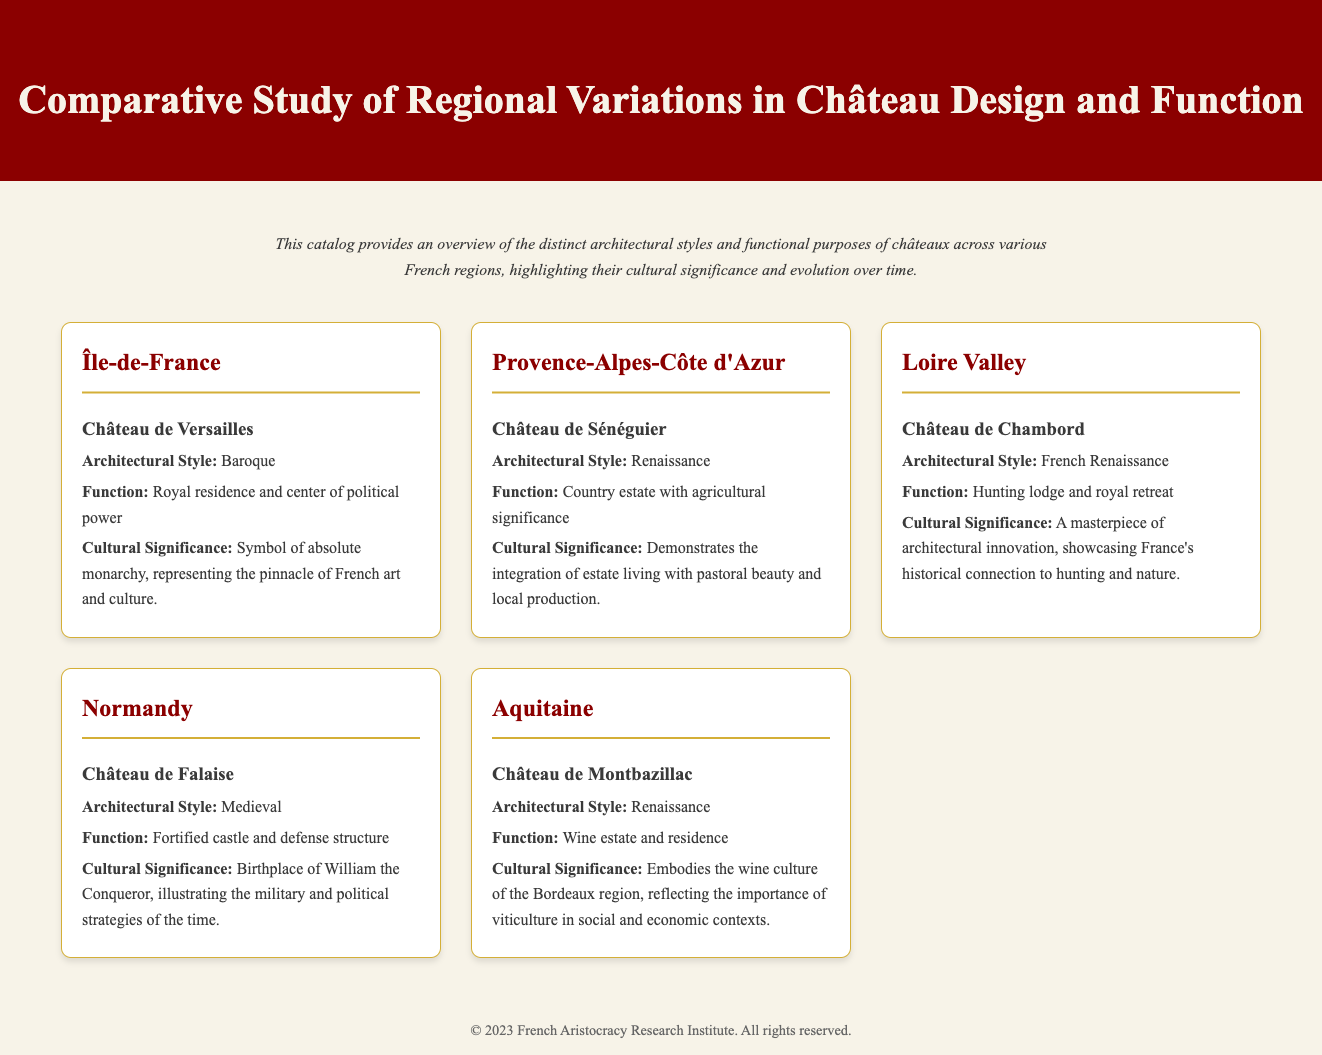What is the architectural style of Château de Versailles? The architectural style is mentioned in its description, which is Baroque.
Answer: Baroque What is the function of Château de Sénéguier? The function is described as a country estate with agricultural significance.
Answer: Country estate with agricultural significance Which château is located in the Loire Valley? The document lists châteaux under their respective regions, and Château de Chambord is identified for the Loire Valley.
Answer: Château de Chambord What cultural significance does Château de Falaise hold? The document states that it is the birthplace of William the Conqueror and illustrates military strategies of the time.
Answer: Birthplace of William the Conqueror What regional variation does Château de Montbazillac represent? The document clearly states that it is located in the Aquitaine region.
Answer: Aquitaine What is the architectural style of Château de Chambord? The architectural style listed is French Renaissance, as specified in the description.
Answer: French Renaissance How many châteaux are described in the document? The document presents a total of five distinct châteaux, each from a different region.
Answer: Five What is the main theme highlighted in the introduction? The introduction mentions the distinct architectural styles and cultural significance of châteaux across regions.
Answer: Distinct architectural styles and cultural significance What is the significance of Château de Sénéguier's design? The document mentions that it demonstrates the integration of estate living with pastoral beauty and local production.
Answer: Integration of estate living with pastoral beauty and local production 